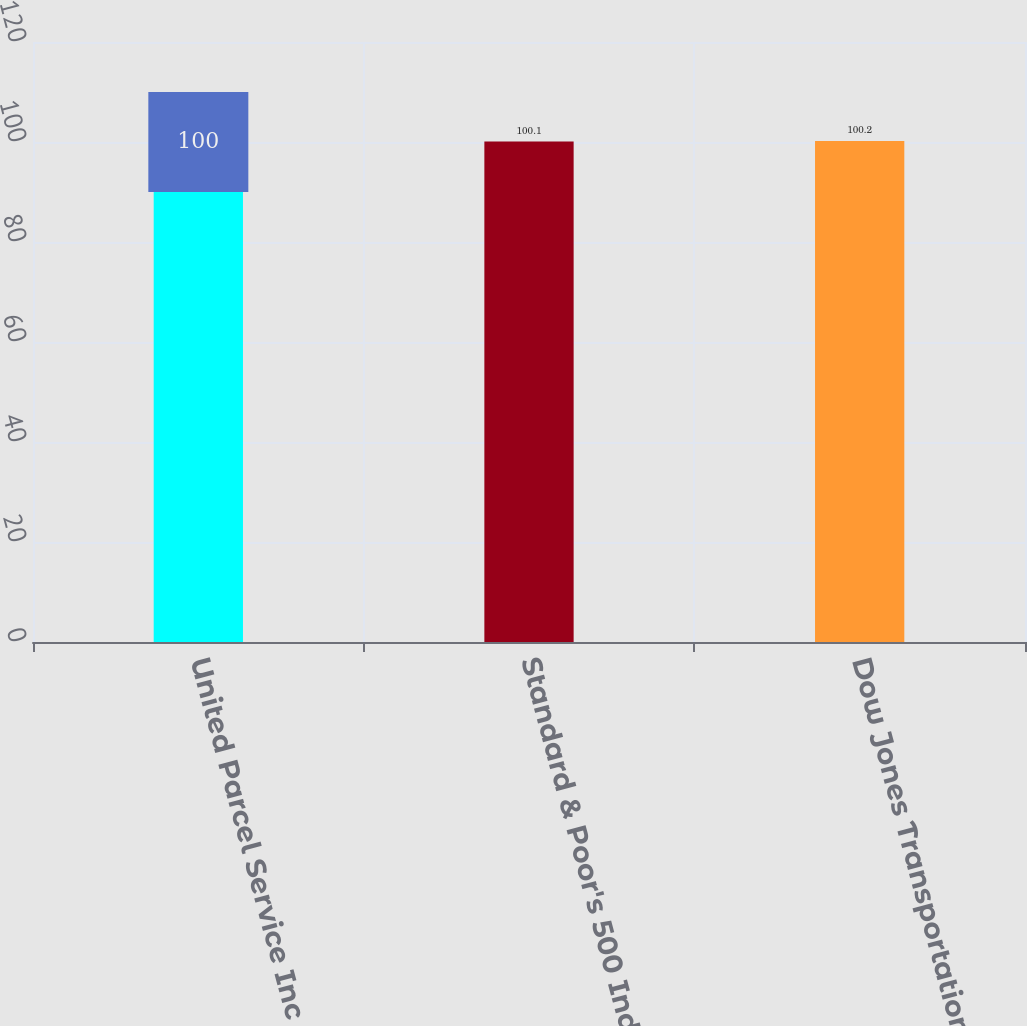Convert chart to OTSL. <chart><loc_0><loc_0><loc_500><loc_500><bar_chart><fcel>United Parcel Service Inc<fcel>Standard & Poor's 500 Index<fcel>Dow Jones Transportation<nl><fcel>100<fcel>100.1<fcel>100.2<nl></chart> 